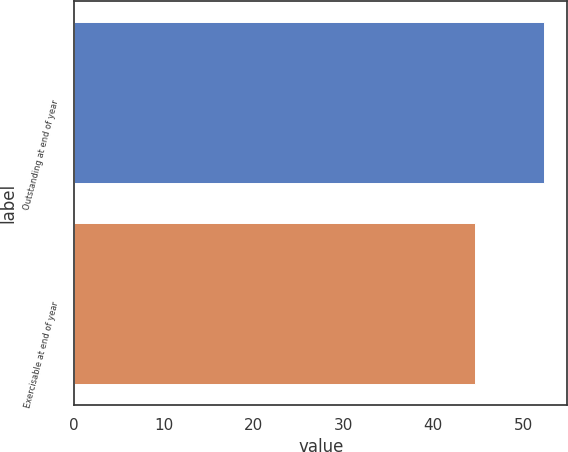<chart> <loc_0><loc_0><loc_500><loc_500><bar_chart><fcel>Outstanding at end of year<fcel>Exercisable at end of year<nl><fcel>52.31<fcel>44.6<nl></chart> 